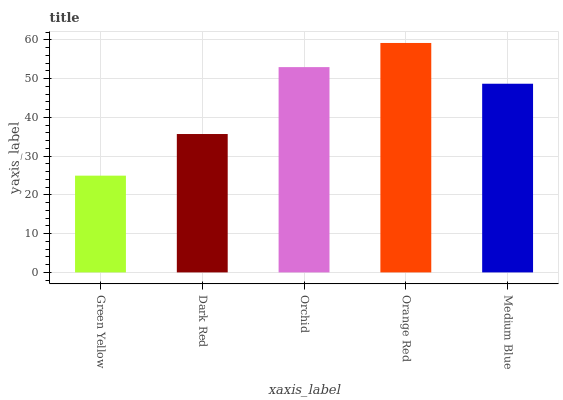Is Green Yellow the minimum?
Answer yes or no. Yes. Is Orange Red the maximum?
Answer yes or no. Yes. Is Dark Red the minimum?
Answer yes or no. No. Is Dark Red the maximum?
Answer yes or no. No. Is Dark Red greater than Green Yellow?
Answer yes or no. Yes. Is Green Yellow less than Dark Red?
Answer yes or no. Yes. Is Green Yellow greater than Dark Red?
Answer yes or no. No. Is Dark Red less than Green Yellow?
Answer yes or no. No. Is Medium Blue the high median?
Answer yes or no. Yes. Is Medium Blue the low median?
Answer yes or no. Yes. Is Orange Red the high median?
Answer yes or no. No. Is Orange Red the low median?
Answer yes or no. No. 